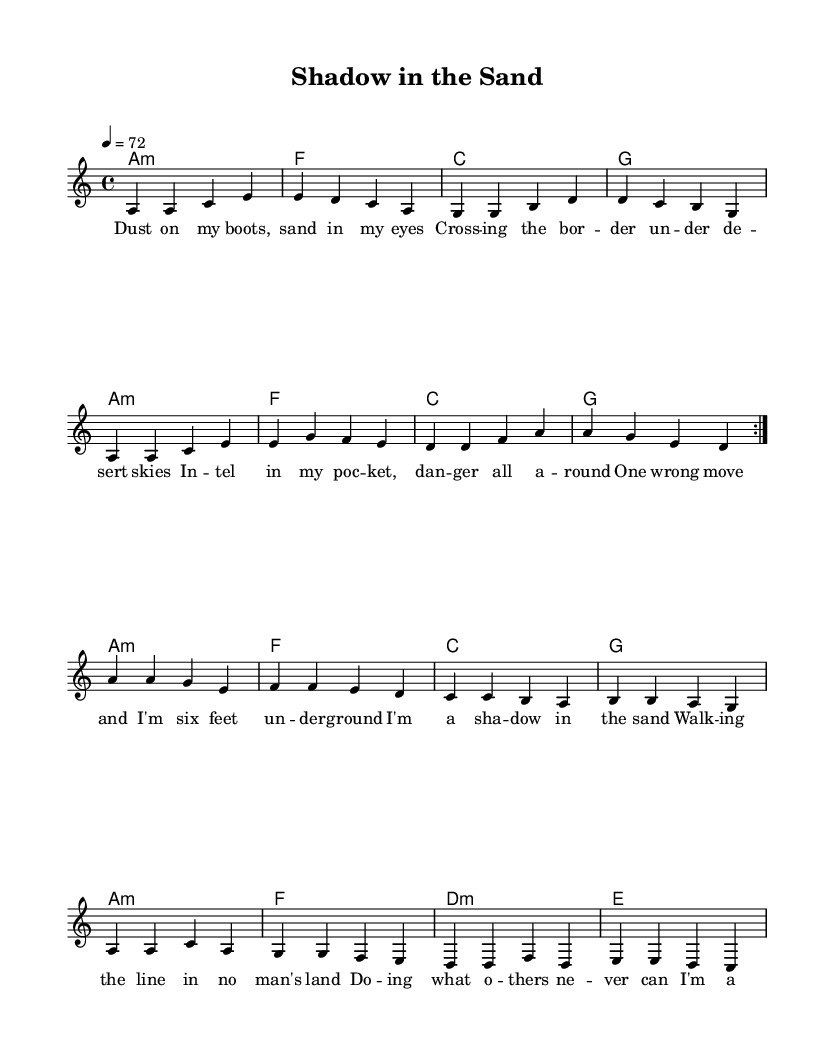What is the key signature of this music? The key signature is A minor, which has no sharps or flats. This can be identified from the global section of the code, which defines the key signature.
Answer: A minor What is the time signature of this music? The time signature is 4/4, indicated in the global section where the time signature is specified. This means there are four beats in each measure.
Answer: 4/4 What is the tempo marking for this piece? The tempo marking is 72 beats per minute, as specified in the global section of the code. This indicates how fast the music should be played.
Answer: 72 How many measures are in the verse section? The verse section contains 8 measures, each represented by a series of note groupings in the verse part of the music.
Answer: 8 What is the structure of the song? The structure consists of two verses followed by a chorus, as noted in the score where the verse is repeated twice before the chorus is played.
Answer: Verse-Chorus What is the subject of the lyrics in this song? The lyrics describe themes of danger and covert operations in challenging environments, characterized by imagery of desert landscapes and espionage. This can be inferred from the wording of the lyrics that reflect the narrative of undercover missions.
Answer: Undercover missions What chord progression is used in the chorus? The chord progression in the chorus is A minor, F, C, G, following the patterns used for harmony within the chorus section. This can be determined by analyzing the harmonies in relation to the chorus part of the music.
Answer: A minor, F, C, G 